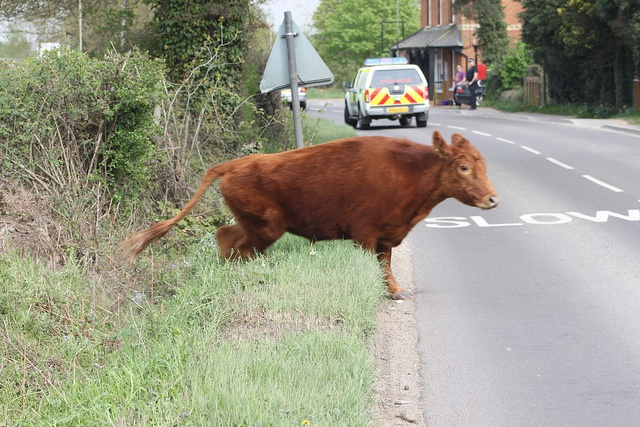Describe the objects in this image and their specific colors. I can see cow in gray, maroon, and brown tones, truck in gray, lightgray, lightblue, darkgray, and black tones, car in gray, lightgray, darkgray, and black tones, car in gray, black, and darkgray tones, and people in gray, black, and lightpink tones in this image. 